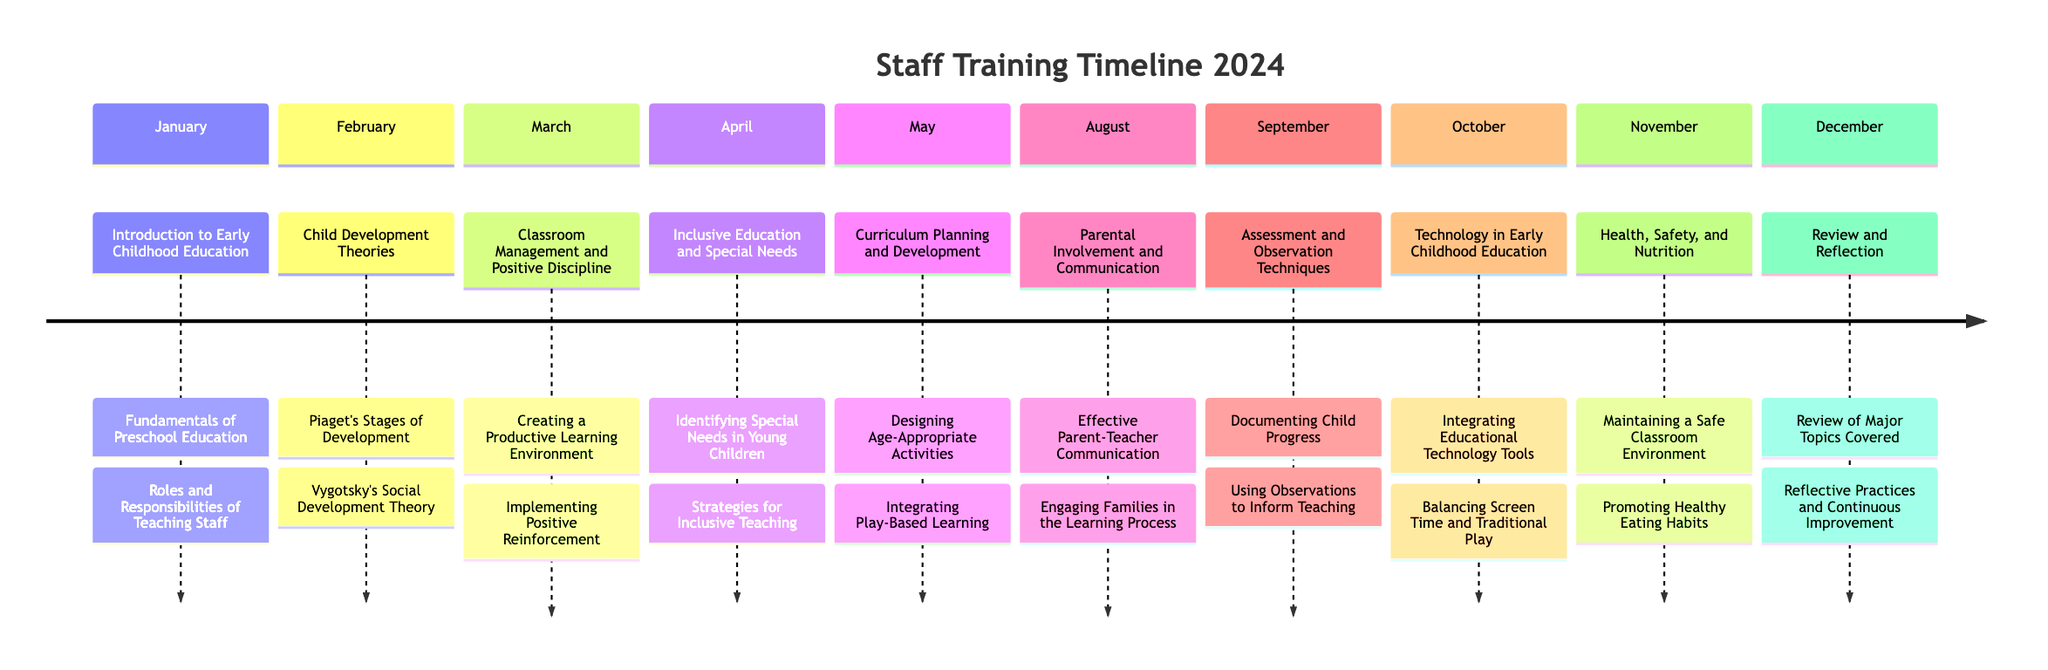What topic is covered in January? The diagram lists "Introduction to Early Childhood Education" as the topic for January.
Answer: Introduction to Early Childhood Education How many training sessions are scheduled for the year? By counting each section (month) in the timeline, we find that there are 11 training sessions scheduled.
Answer: 11 What topic is covered in October? The diagram specifies that "Technology in Early Childhood Education" is the topic for October.
Answer: Technology in Early Childhood Education Which month covers "Review and Reflection"? According to the timeline, "Review and Reflection" is covered in December.
Answer: December What are the subtopics of "Curriculum Planning and Development"? From the diagram, the subtopics under "Curriculum Planning and Development" are "Designing Age-Appropriate Activities" and "Integrating Play-Based Learning."
Answer: Designing Age-Appropriate Activities, Integrating Play-Based Learning Which topic focuses on engaging families? The topic that focuses on engaging families is listed as "Parental Involvement and Communication."
Answer: Parental Involvement and Communication Which month is dedicated to Health, Safety, and Nutrition? The timeline indicates that health-related topics are scheduled for November under "Health, Safety, and Nutrition."
Answer: November What are the two major theories discussed in February? In February, the theories discussed are "Piaget's Stages of Development" and "Vygotsky's Social Development Theory."
Answer: Piaget's Stages of Development, Vygotsky's Social Development Theory How does the training in April differ from that in March? The training in April focuses on "Inclusive Education and Special Needs", while March is about "Classroom Management and Positive Discipline."
Answer: Inclusive Education and Special Needs differs from Classroom Management and Positive Discipline 